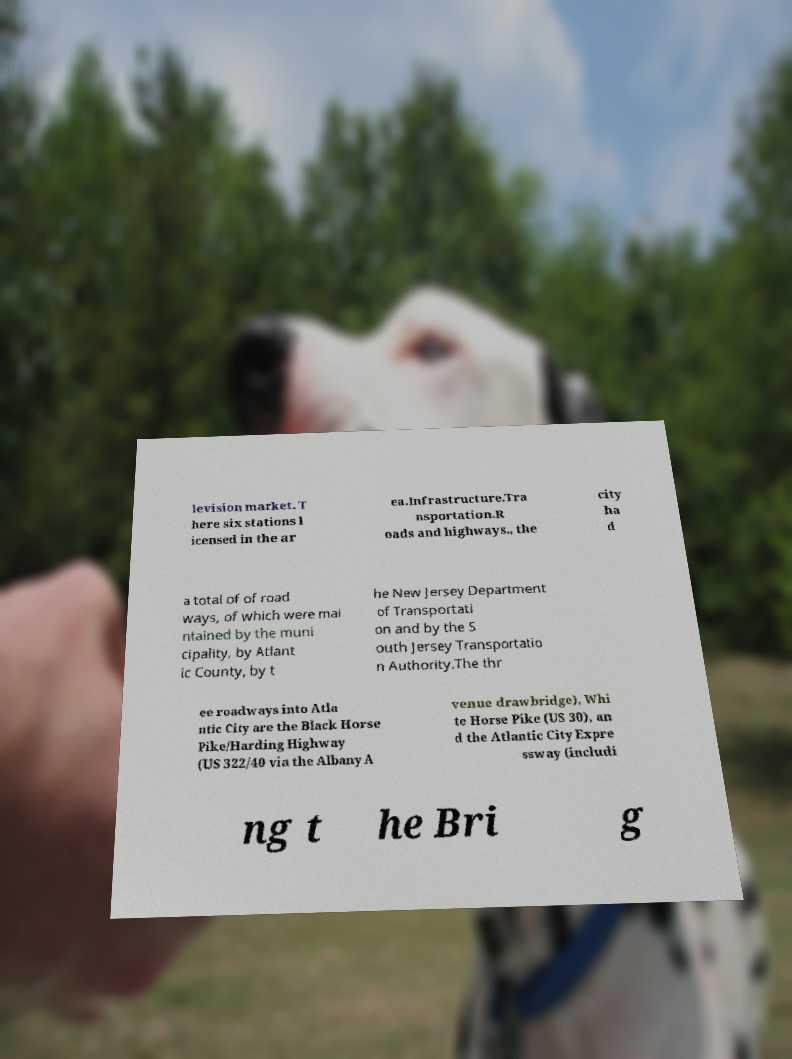Please read and relay the text visible in this image. What does it say? levision market. T here six stations l icensed in the ar ea.Infrastructure.Tra nsportation.R oads and highways., the city ha d a total of of road ways, of which were mai ntained by the muni cipality, by Atlant ic County, by t he New Jersey Department of Transportati on and by the S outh Jersey Transportatio n Authority.The thr ee roadways into Atla ntic City are the Black Horse Pike/Harding Highway (US 322/40 via the Albany A venue drawbridge), Whi te Horse Pike (US 30), an d the Atlantic City Expre ssway (includi ng t he Bri g 